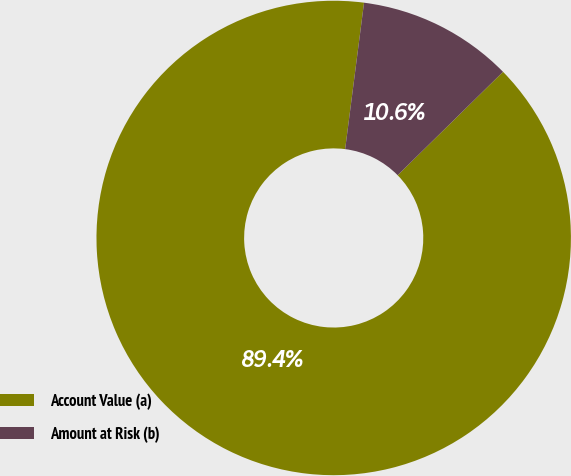Convert chart. <chart><loc_0><loc_0><loc_500><loc_500><pie_chart><fcel>Account Value (a)<fcel>Amount at Risk (b)<nl><fcel>89.39%<fcel>10.61%<nl></chart> 